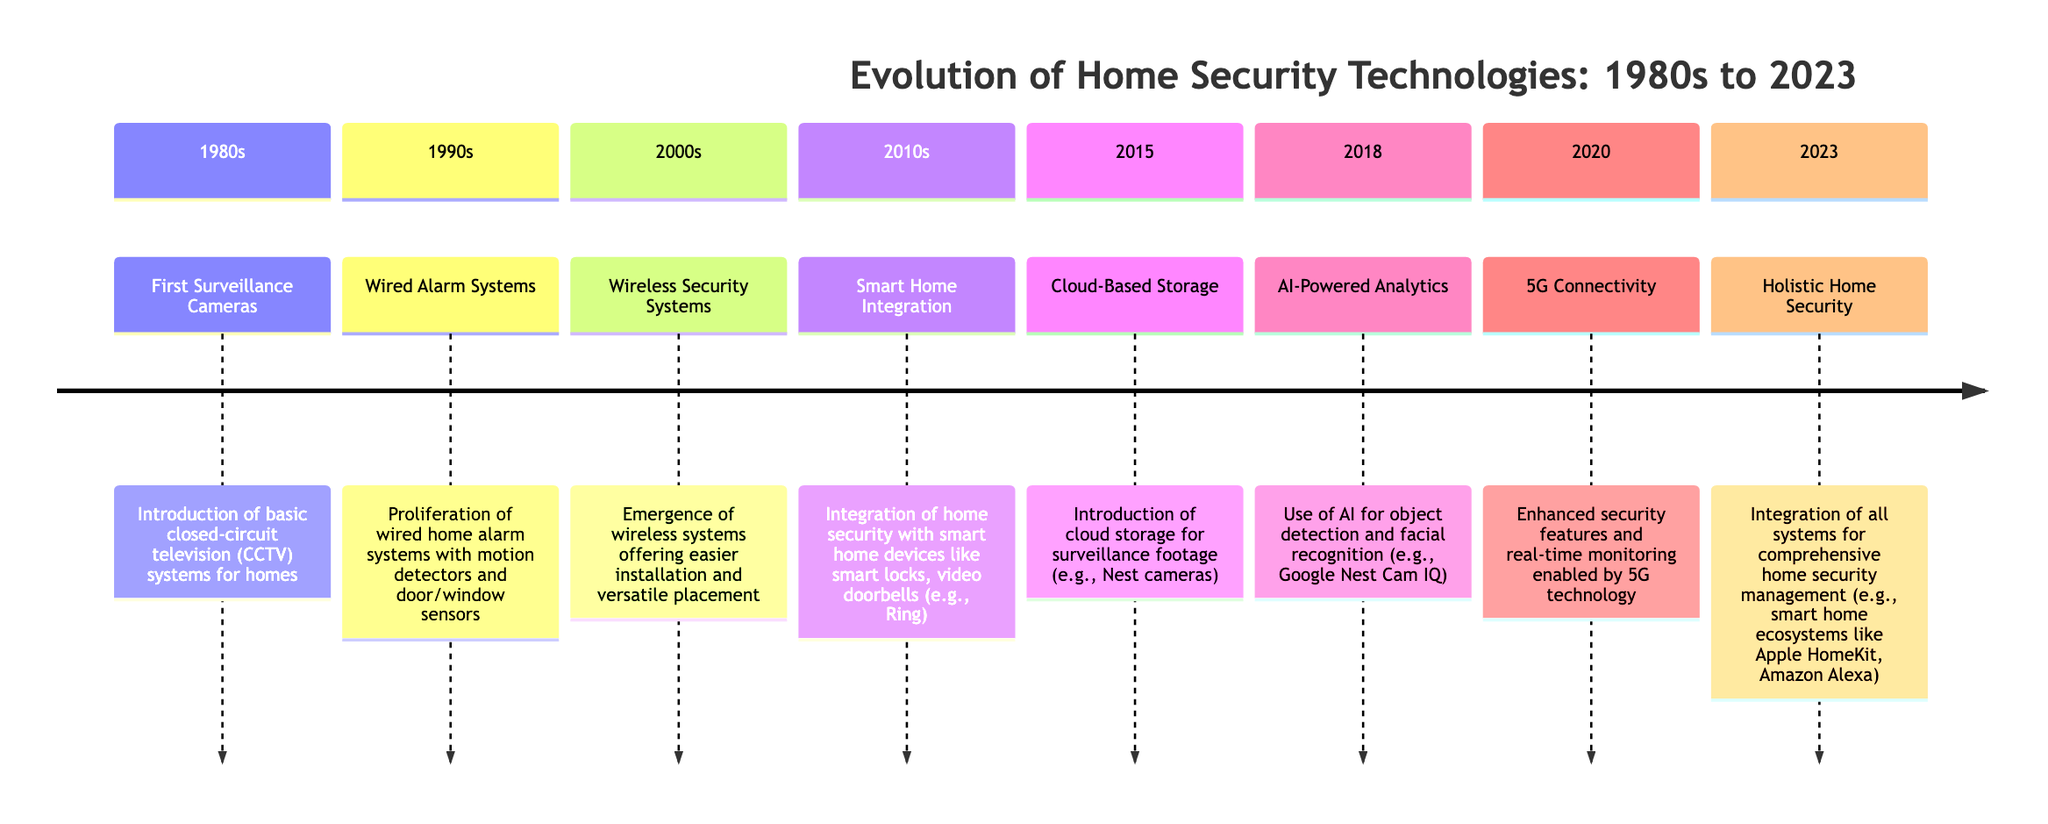What technological advancement was introduced in the 1990s? The diagram indicates that the 1990s saw the proliferation of wired home alarm systems, which included motion detectors and door/window sensors. This textual information directly informs us about the specific advancement during this decade.
Answer: Wired Alarm Systems How many years is there between the introduction of Smart Home Integration and AI-Powered Analytics? Smart Home Integration was mentioned in the 2010s and AI-Powered Analytics was noted in 2018. Calculating the year difference between these two points (2018 - 2010) gives us 8 years.
Answer: 8 years What technology enabled enhanced security features in 2020? The diagram states that enhanced security features in 2020 were enabled by 5G technology. This information is a straightforward reference from the timeline.
Answer: 5G Technology What does the holistic home security in 2023 represent? The diagram illustrates that in 2023, holistic home security denotes the integration of all systems for comprehensive home security management. This understanding comes directly from the textual explanation given for that year.
Answer: Integration of all systems What significant change occurred in home security in the 2000s compared to the 1990s? In the 1990s, wired systems were prevalent, while the 2000s introduced wireless security systems that offered easier installation and versatile placement. This comparison covers the transition in technology types between these decades.
Answer: Wireless Security Systems 